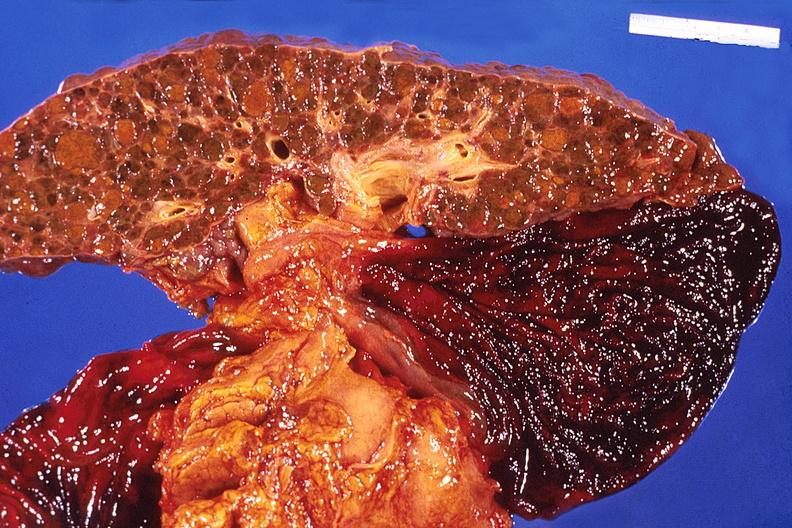does this image show liver, cirrhosis and enlarged gall bladder?
Answer the question using a single word or phrase. Yes 